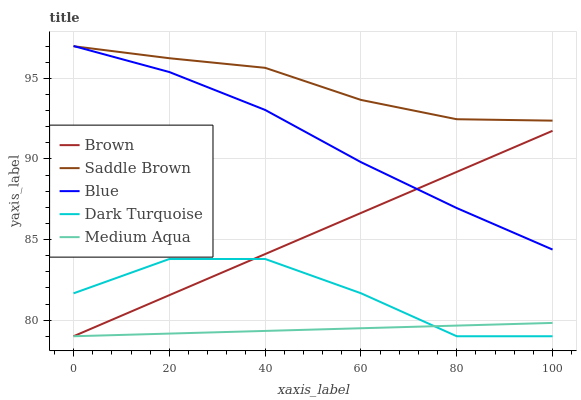Does Medium Aqua have the minimum area under the curve?
Answer yes or no. Yes. Does Saddle Brown have the maximum area under the curve?
Answer yes or no. Yes. Does Brown have the minimum area under the curve?
Answer yes or no. No. Does Brown have the maximum area under the curve?
Answer yes or no. No. Is Brown the smoothest?
Answer yes or no. Yes. Is Dark Turquoise the roughest?
Answer yes or no. Yes. Is Medium Aqua the smoothest?
Answer yes or no. No. Is Medium Aqua the roughest?
Answer yes or no. No. Does Brown have the lowest value?
Answer yes or no. Yes. Does Saddle Brown have the lowest value?
Answer yes or no. No. Does Blue have the highest value?
Answer yes or no. Yes. Does Brown have the highest value?
Answer yes or no. No. Is Dark Turquoise less than Saddle Brown?
Answer yes or no. Yes. Is Saddle Brown greater than Dark Turquoise?
Answer yes or no. Yes. Does Brown intersect Medium Aqua?
Answer yes or no. Yes. Is Brown less than Medium Aqua?
Answer yes or no. No. Is Brown greater than Medium Aqua?
Answer yes or no. No. Does Dark Turquoise intersect Saddle Brown?
Answer yes or no. No. 